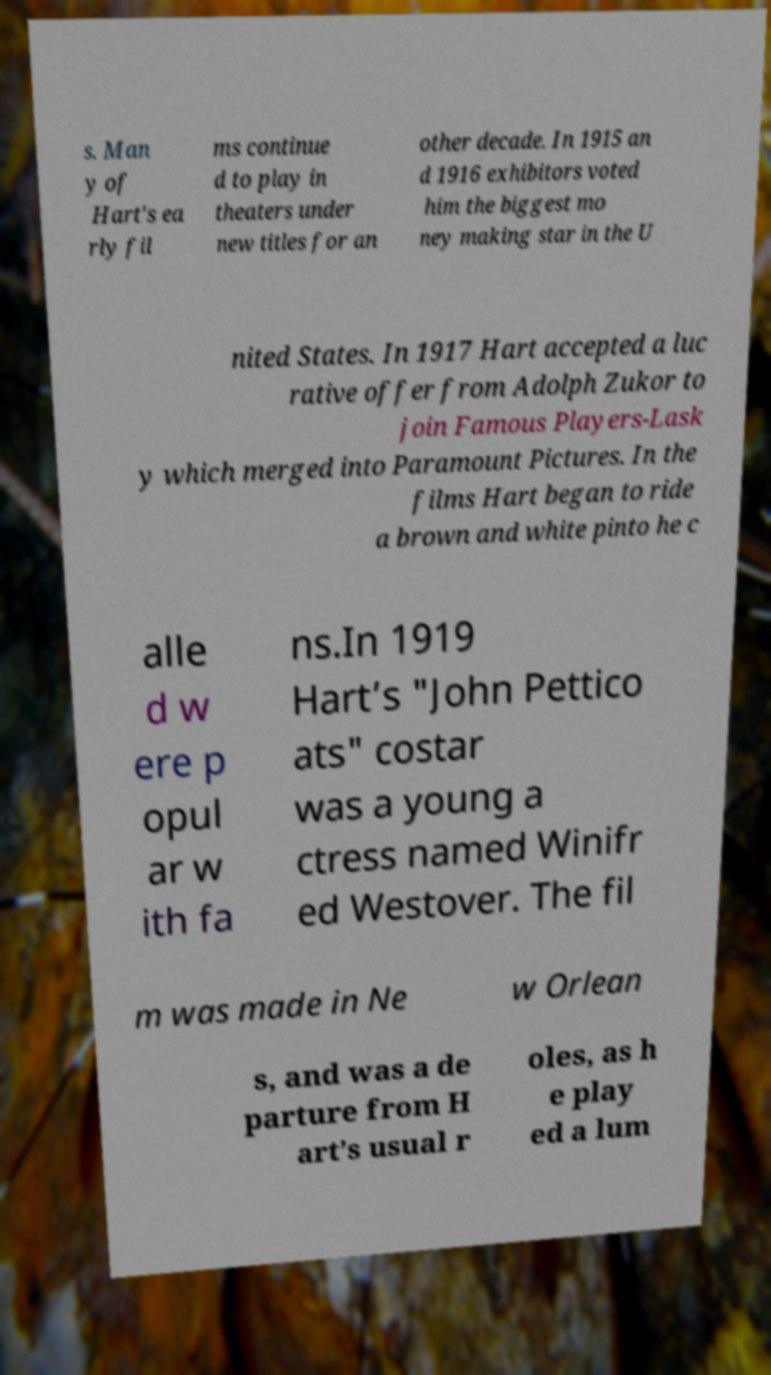Please identify and transcribe the text found in this image. s. Man y of Hart's ea rly fil ms continue d to play in theaters under new titles for an other decade. In 1915 an d 1916 exhibitors voted him the biggest mo ney making star in the U nited States. In 1917 Hart accepted a luc rative offer from Adolph Zukor to join Famous Players-Lask y which merged into Paramount Pictures. In the films Hart began to ride a brown and white pinto he c alle d w ere p opul ar w ith fa ns.In 1919 Hart’s "John Pettico ats" costar was a young a ctress named Winifr ed Westover. The fil m was made in Ne w Orlean s, and was a de parture from H art’s usual r oles, as h e play ed a lum 